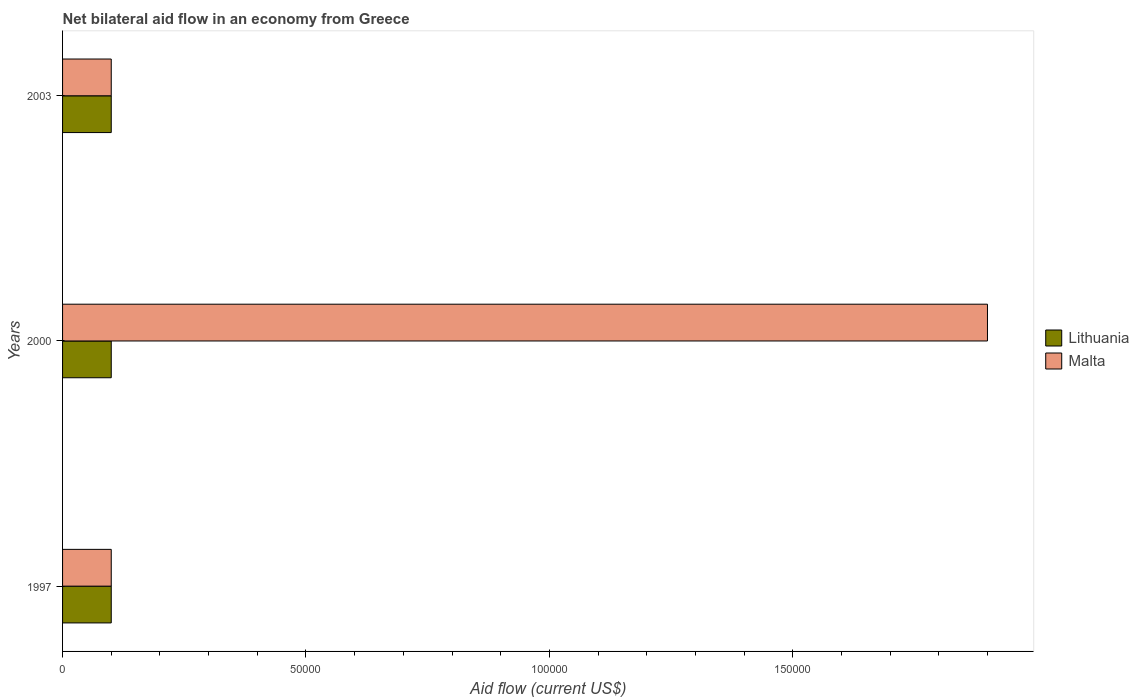How many different coloured bars are there?
Your response must be concise. 2. How many groups of bars are there?
Your answer should be compact. 3. Are the number of bars on each tick of the Y-axis equal?
Keep it short and to the point. Yes. How many bars are there on the 1st tick from the top?
Give a very brief answer. 2. What is the label of the 2nd group of bars from the top?
Your answer should be compact. 2000. In how many cases, is the number of bars for a given year not equal to the number of legend labels?
Your response must be concise. 0. What is the net bilateral aid flow in Malta in 2000?
Provide a succinct answer. 1.90e+05. Across all years, what is the minimum net bilateral aid flow in Malta?
Offer a very short reply. 10000. In which year was the net bilateral aid flow in Lithuania minimum?
Provide a short and direct response. 1997. What is the total net bilateral aid flow in Malta in the graph?
Your response must be concise. 2.10e+05. In the year 2003, what is the difference between the net bilateral aid flow in Malta and net bilateral aid flow in Lithuania?
Offer a very short reply. 0. Is the net bilateral aid flow in Lithuania in 1997 less than that in 2003?
Provide a succinct answer. No. Is the difference between the net bilateral aid flow in Malta in 1997 and 2003 greater than the difference between the net bilateral aid flow in Lithuania in 1997 and 2003?
Make the answer very short. No. What is the difference between the highest and the second highest net bilateral aid flow in Malta?
Make the answer very short. 1.80e+05. In how many years, is the net bilateral aid flow in Lithuania greater than the average net bilateral aid flow in Lithuania taken over all years?
Your answer should be compact. 0. What does the 2nd bar from the top in 2003 represents?
Make the answer very short. Lithuania. What does the 2nd bar from the bottom in 2003 represents?
Your answer should be very brief. Malta. How many bars are there?
Make the answer very short. 6. Are all the bars in the graph horizontal?
Make the answer very short. Yes. Does the graph contain grids?
Ensure brevity in your answer.  No. Where does the legend appear in the graph?
Offer a very short reply. Center right. How many legend labels are there?
Ensure brevity in your answer.  2. What is the title of the graph?
Make the answer very short. Net bilateral aid flow in an economy from Greece. Does "Sudan" appear as one of the legend labels in the graph?
Keep it short and to the point. No. What is the label or title of the Y-axis?
Your answer should be compact. Years. What is the Aid flow (current US$) of Lithuania in 1997?
Give a very brief answer. 10000. What is the Aid flow (current US$) of Lithuania in 2003?
Offer a terse response. 10000. Across all years, what is the maximum Aid flow (current US$) in Malta?
Your response must be concise. 1.90e+05. What is the difference between the Aid flow (current US$) in Malta in 1997 and that in 2000?
Ensure brevity in your answer.  -1.80e+05. What is the difference between the Aid flow (current US$) in Lithuania in 1997 and that in 2003?
Offer a very short reply. 0. What is the difference between the Aid flow (current US$) of Lithuania in 1997 and the Aid flow (current US$) of Malta in 2003?
Give a very brief answer. 0. What is the average Aid flow (current US$) of Malta per year?
Provide a succinct answer. 7.00e+04. In the year 1997, what is the difference between the Aid flow (current US$) of Lithuania and Aid flow (current US$) of Malta?
Keep it short and to the point. 0. In the year 2000, what is the difference between the Aid flow (current US$) in Lithuania and Aid flow (current US$) in Malta?
Provide a succinct answer. -1.80e+05. What is the ratio of the Aid flow (current US$) in Malta in 1997 to that in 2000?
Your answer should be compact. 0.05. What is the ratio of the Aid flow (current US$) of Lithuania in 1997 to that in 2003?
Your answer should be very brief. 1. What is the ratio of the Aid flow (current US$) in Lithuania in 2000 to that in 2003?
Your response must be concise. 1. What is the ratio of the Aid flow (current US$) in Malta in 2000 to that in 2003?
Offer a terse response. 19. What is the difference between the highest and the second highest Aid flow (current US$) in Lithuania?
Ensure brevity in your answer.  0. What is the difference between the highest and the second highest Aid flow (current US$) of Malta?
Ensure brevity in your answer.  1.80e+05. 